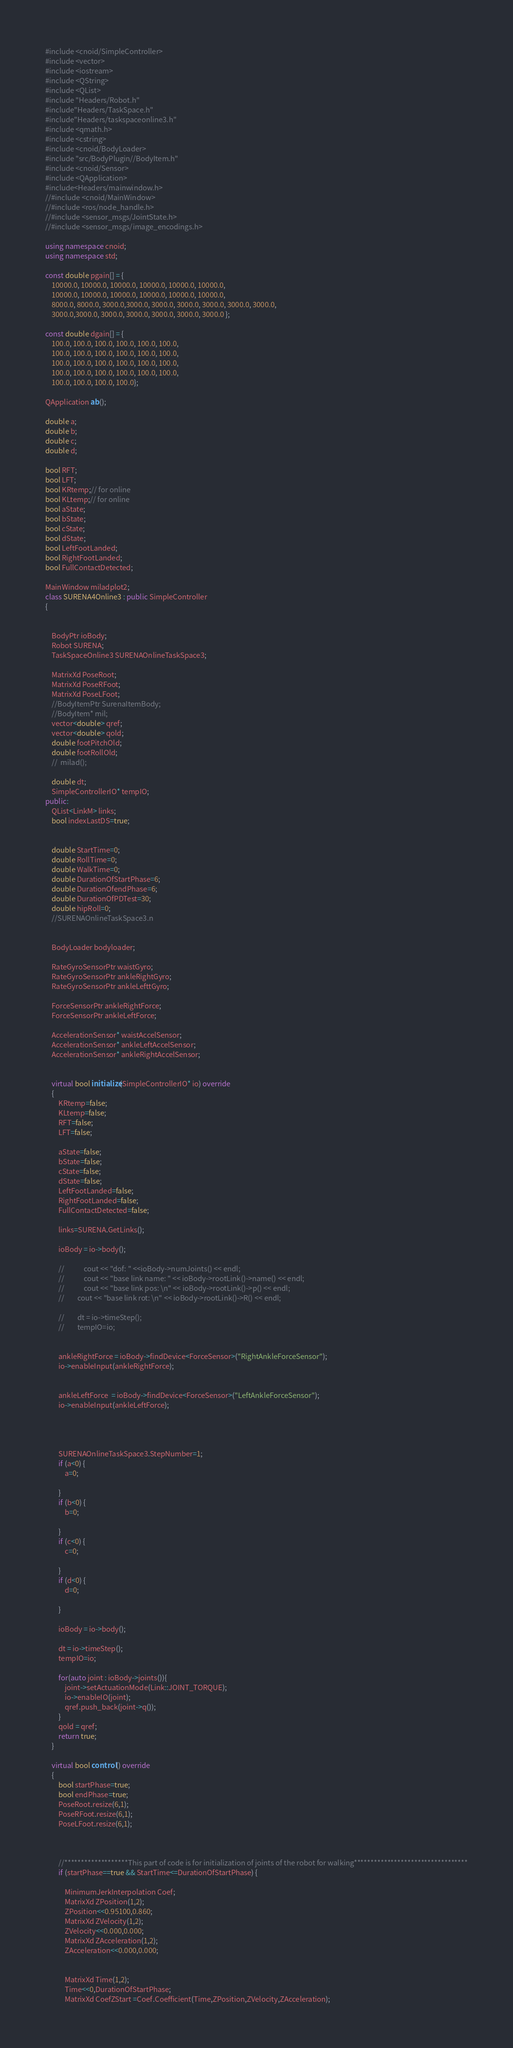Convert code to text. <code><loc_0><loc_0><loc_500><loc_500><_C++_>
#include <cnoid/SimpleController>
#include <vector>
#include <iostream>
#include <QString>
#include <QList>
#include "Headers/Robot.h"
#include"Headers/TaskSpace.h"
#include"Headers/taskspaceonline3.h"
#include <qmath.h>
#include <cstring>
#include <cnoid/BodyLoader>
#include "src/BodyPlugin//BodyItem.h"
#include <cnoid/Sensor>
#include <QApplication>
#include<Headers/mainwindow.h>
//#include <cnoid/MainWindow>
//#include <ros/node_handle.h>
//#include <sensor_msgs/JointState.h>
//#include <sensor_msgs/image_encodings.h>

using namespace cnoid;
using namespace std;

const double pgain[] = {
    10000.0, 10000.0, 10000.0, 10000.0, 10000.0, 10000.0,
    10000.0, 10000.0, 10000.0, 10000.0, 10000.0, 10000.0,
    8000.0, 8000.0, 3000.0,3000.0, 3000.0, 3000.0, 3000.0, 3000.0, 3000.0,
    3000.0,3000.0, 3000.0, 3000.0, 3000.0, 3000.0, 3000.0 };

const double dgain[] = {
    100.0, 100.0, 100.0, 100.0, 100.0, 100.0,
    100.0, 100.0, 100.0, 100.0, 100.0, 100.0,
    100.0, 100.0, 100.0, 100.0, 100.0, 100.0,
    100.0, 100.0, 100.0, 100.0, 100.0, 100.0,
    100.0, 100.0, 100.0, 100.0};

QApplication ab();

double a;
double b;
double c;
double d;

bool RFT;
bool LFT;
bool KRtemp;// for online
bool KLtemp;// for online
bool aState;
bool bState;
bool cState;
bool dState;
bool LeftFootLanded;
bool RightFootLanded;
bool FullContactDetected;

MainWindow miladplot2;
class SURENA4Online3 : public SimpleController
{


    BodyPtr ioBody;
    Robot SURENA;
    TaskSpaceOnline3 SURENAOnlineTaskSpace3;

    MatrixXd PoseRoot;
    MatrixXd PoseRFoot;
    MatrixXd PoseLFoot;
    //BodyItemPtr SurenaItemBody;
    //BodyItem* mil;
    vector<double> qref;
    vector<double> qold;
    double footPitchOld;
    double footRollOld;
    //  milad();

    double dt;
    SimpleControllerIO* tempIO;
public:
    QList<LinkM> links;
    bool indexLastDS=true;


    double StartTime=0;
    double RollTime=0;
    double WalkTime=0;
    double DurationOfStartPhase=6;
    double DurationOfendPhase=6;
    double DurationOfPDTest=30;
    double hipRoll=0;
    //SURENAOnlineTaskSpace3.n


    BodyLoader bodyloader;

    RateGyroSensorPtr waistGyro;
    RateGyroSensorPtr ankleRightGyro;
    RateGyroSensorPtr ankleLefttGyro;

    ForceSensorPtr ankleRightForce;
    ForceSensorPtr ankleLeftForce;

    AccelerationSensor* waistAccelSensor;
    AccelerationSensor* ankleLeftAccelSensor;
    AccelerationSensor* ankleRightAccelSensor;


    virtual bool initialize(SimpleControllerIO* io) override
    {
        KRtemp=false;
        KLtemp=false;
        RFT=false;
        LFT=false;

        aState=false;
        bState=false;
        cState=false;
        dState=false;
        LeftFootLanded=false;
        RightFootLanded=false;
        FullContactDetected=false;

        links=SURENA.GetLinks();

        ioBody = io->body();

        //            cout << "dof: " <<ioBody->numJoints() << endl;
        //            cout << "base link name: " << ioBody->rootLink()->name() << endl;
        //            cout << "base link pos: \n" << ioBody->rootLink()->p() << endl;
        //        cout << "base link rot: \n" << ioBody->rootLink()->R() << endl;

        //        dt = io->timeStep();
        //        tempIO=io;


        ankleRightForce = ioBody->findDevice<ForceSensor>("RightAnkleForceSensor");
        io->enableInput(ankleRightForce);


        ankleLeftForce  = ioBody->findDevice<ForceSensor>("LeftAnkleForceSensor");
        io->enableInput(ankleLeftForce);




        SURENAOnlineTaskSpace3.StepNumber=1;
        if (a<0) {
            a=0;

        }
        if (b<0) {
            b=0;

        }
        if (c<0) {
            c=0;

        }
        if (d<0) {
            d=0;

        }

        ioBody = io->body();

        dt = io->timeStep();
        tempIO=io;

        for(auto joint : ioBody->joints()){
            joint->setActuationMode(Link::JOINT_TORQUE);
            io->enableIO(joint);
            qref.push_back(joint->q());
        }
        qold = qref;
        return true;
    }

    virtual bool control() override
    {
        bool startPhase=true;
        bool endPhase=true;
        PoseRoot.resize(6,1);
        PoseRFoot.resize(6,1);
        PoseLFoot.resize(6,1);



        //*******************This part of code is for initialization of joints of the robot for walking**********************************
        if (startPhase==true && StartTime<=DurationOfStartPhase) {

            MinimumJerkInterpolation Coef;
            MatrixXd ZPosition(1,2);
            ZPosition<<0.95100,0.860;
            MatrixXd ZVelocity(1,2);
            ZVelocity<<0.000,0.000;
            MatrixXd ZAcceleration(1,2);
            ZAcceleration<<0.000,0.000;


            MatrixXd Time(1,2);
            Time<<0,DurationOfStartPhase;
            MatrixXd CoefZStart =Coef.Coefficient(Time,ZPosition,ZVelocity,ZAcceleration);
</code> 